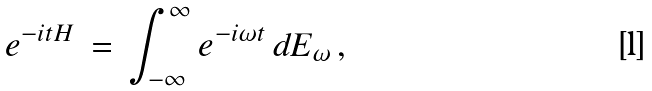<formula> <loc_0><loc_0><loc_500><loc_500>e ^ { - i t H } \, = \, \int _ { - \infty } ^ { \infty } e ^ { - i \omega t } \, d E _ { \omega } \, ,</formula> 